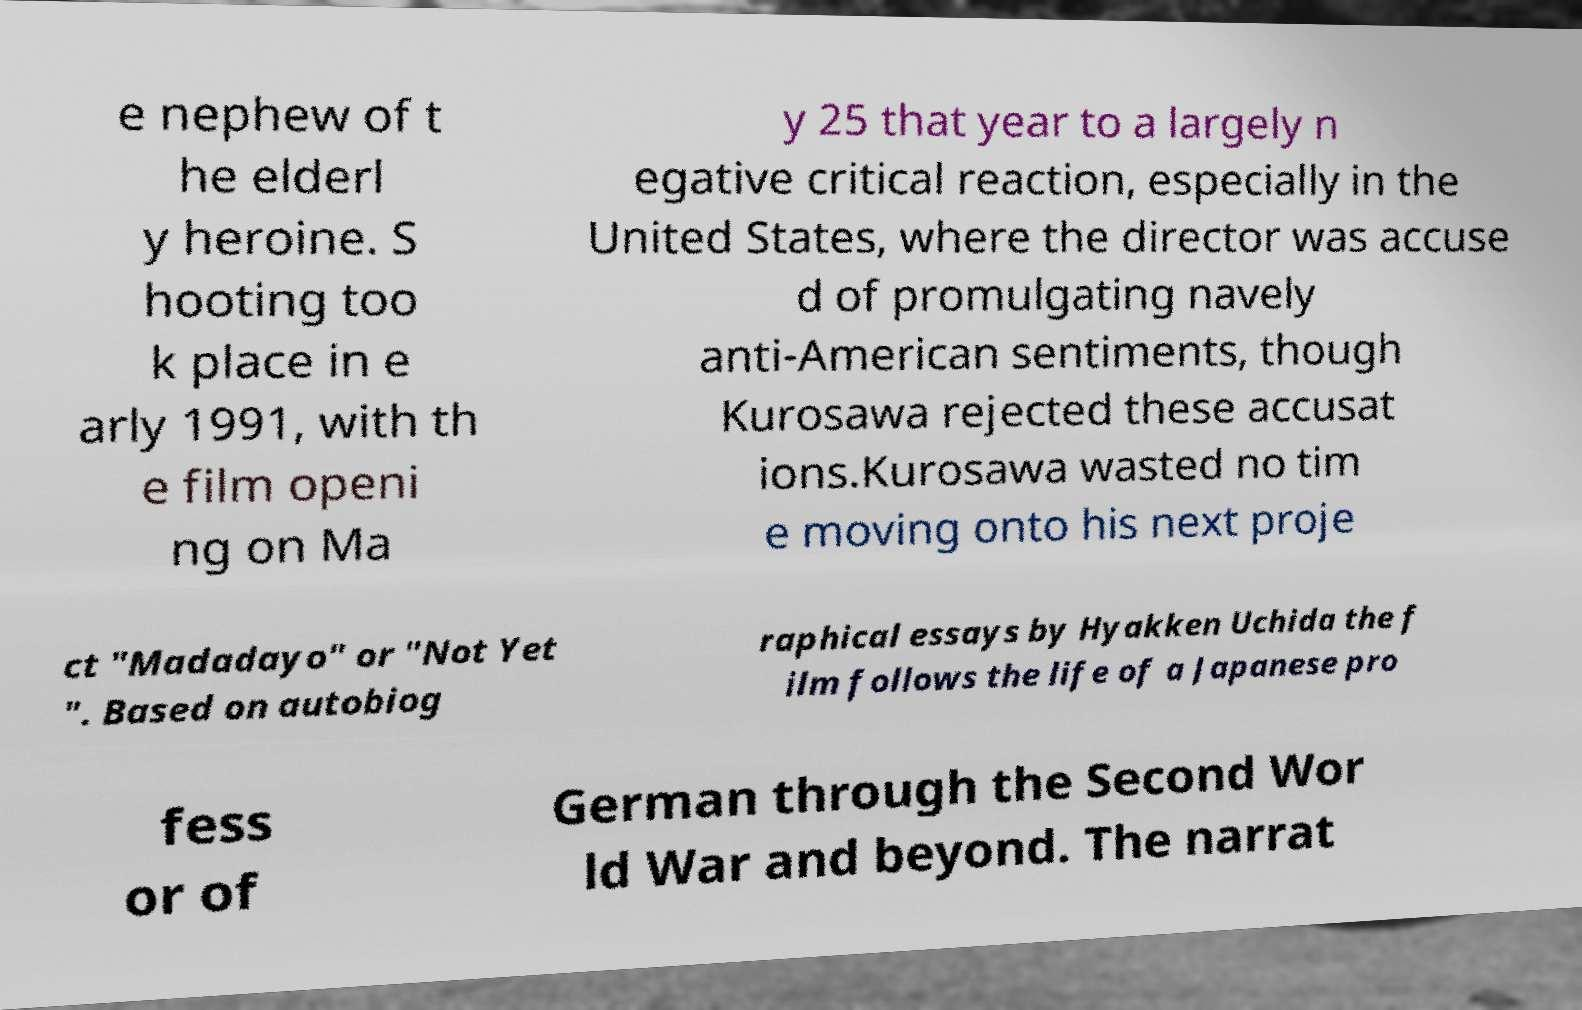There's text embedded in this image that I need extracted. Can you transcribe it verbatim? e nephew of t he elderl y heroine. S hooting too k place in e arly 1991, with th e film openi ng on Ma y 25 that year to a largely n egative critical reaction, especially in the United States, where the director was accuse d of promulgating navely anti-American sentiments, though Kurosawa rejected these accusat ions.Kurosawa wasted no tim e moving onto his next proje ct "Madadayo" or "Not Yet ". Based on autobiog raphical essays by Hyakken Uchida the f ilm follows the life of a Japanese pro fess or of German through the Second Wor ld War and beyond. The narrat 